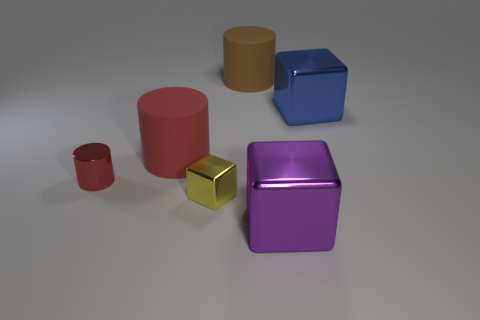Add 1 blocks. How many objects exist? 7 Subtract all tiny blue rubber blocks. Subtract all small red things. How many objects are left? 5 Add 5 small yellow metallic things. How many small yellow metallic things are left? 6 Add 4 tiny things. How many tiny things exist? 6 Subtract 1 yellow cubes. How many objects are left? 5 